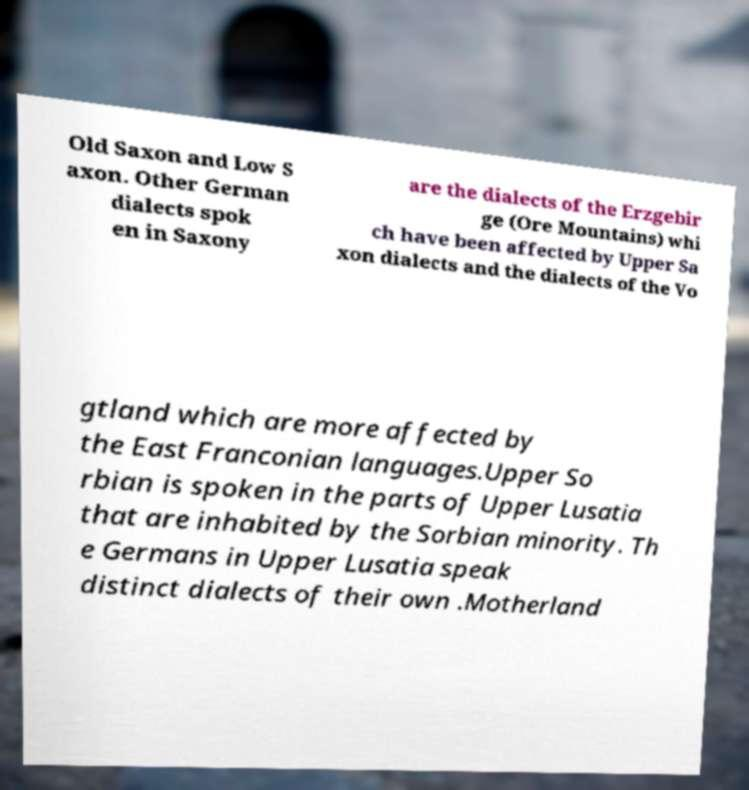I need the written content from this picture converted into text. Can you do that? Old Saxon and Low S axon. Other German dialects spok en in Saxony are the dialects of the Erzgebir ge (Ore Mountains) whi ch have been affected by Upper Sa xon dialects and the dialects of the Vo gtland which are more affected by the East Franconian languages.Upper So rbian is spoken in the parts of Upper Lusatia that are inhabited by the Sorbian minority. Th e Germans in Upper Lusatia speak distinct dialects of their own .Motherland 